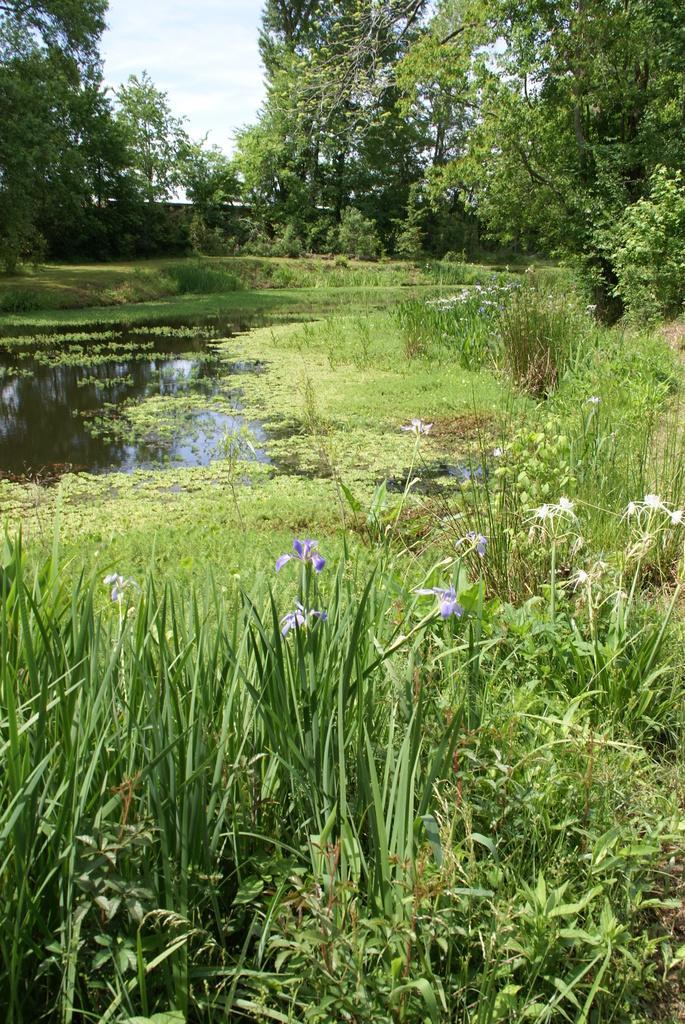Can you describe this image briefly? In this image at the bottom there are some plants, flowers, grass and small pond. In the background there are some trees and wall, at the top of the image there is sky. 